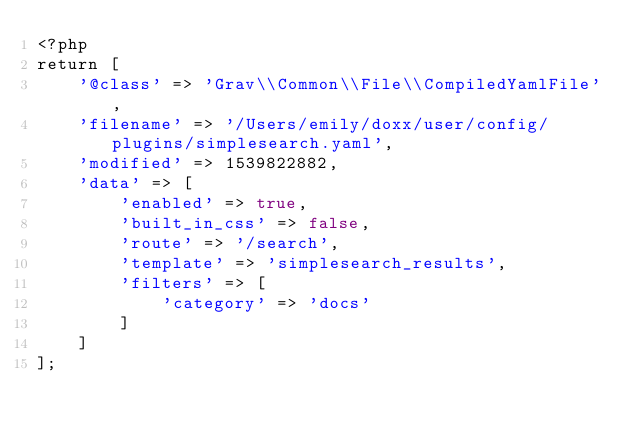Convert code to text. <code><loc_0><loc_0><loc_500><loc_500><_PHP_><?php
return [
    '@class' => 'Grav\\Common\\File\\CompiledYamlFile',
    'filename' => '/Users/emily/doxx/user/config/plugins/simplesearch.yaml',
    'modified' => 1539822882,
    'data' => [
        'enabled' => true,
        'built_in_css' => false,
        'route' => '/search',
        'template' => 'simplesearch_results',
        'filters' => [
            'category' => 'docs'
        ]
    ]
];
</code> 